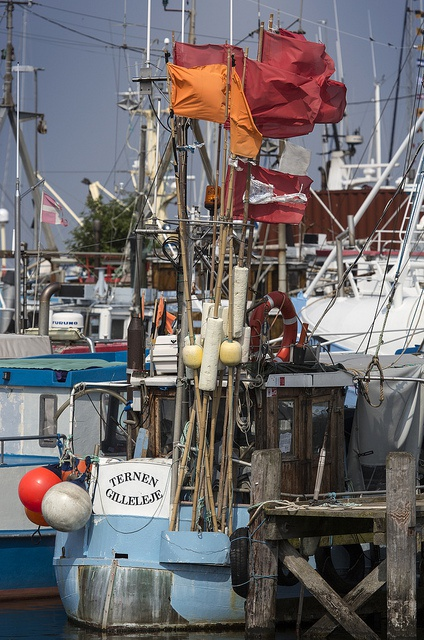Describe the objects in this image and their specific colors. I can see boat in gray, darkgray, black, and lightgray tones and boat in gray, darkgray, black, and darkblue tones in this image. 